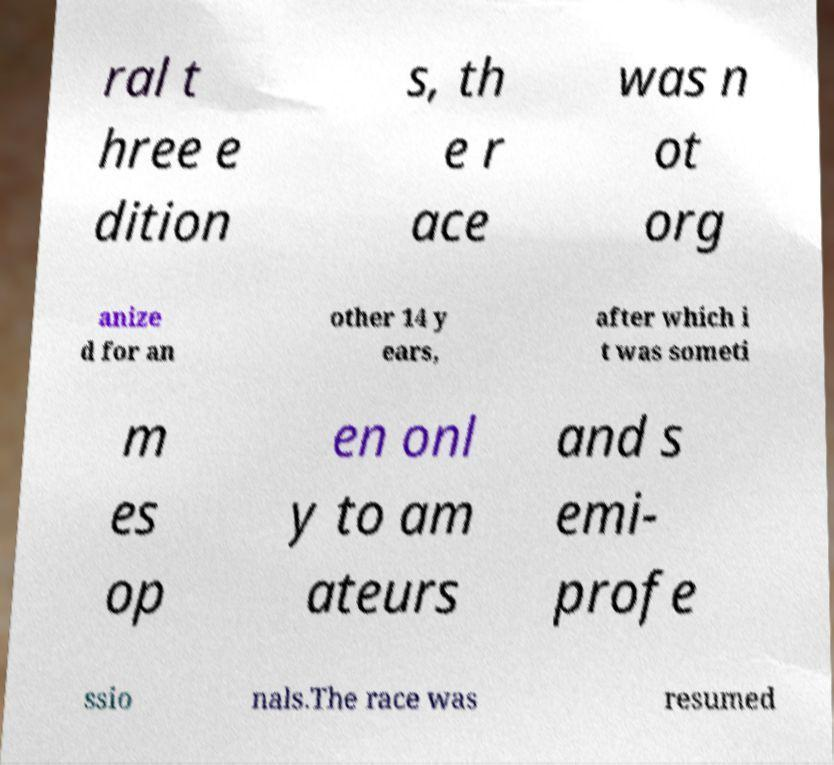Please identify and transcribe the text found in this image. ral t hree e dition s, th e r ace was n ot org anize d for an other 14 y ears, after which i t was someti m es op en onl y to am ateurs and s emi- profe ssio nals.The race was resumed 